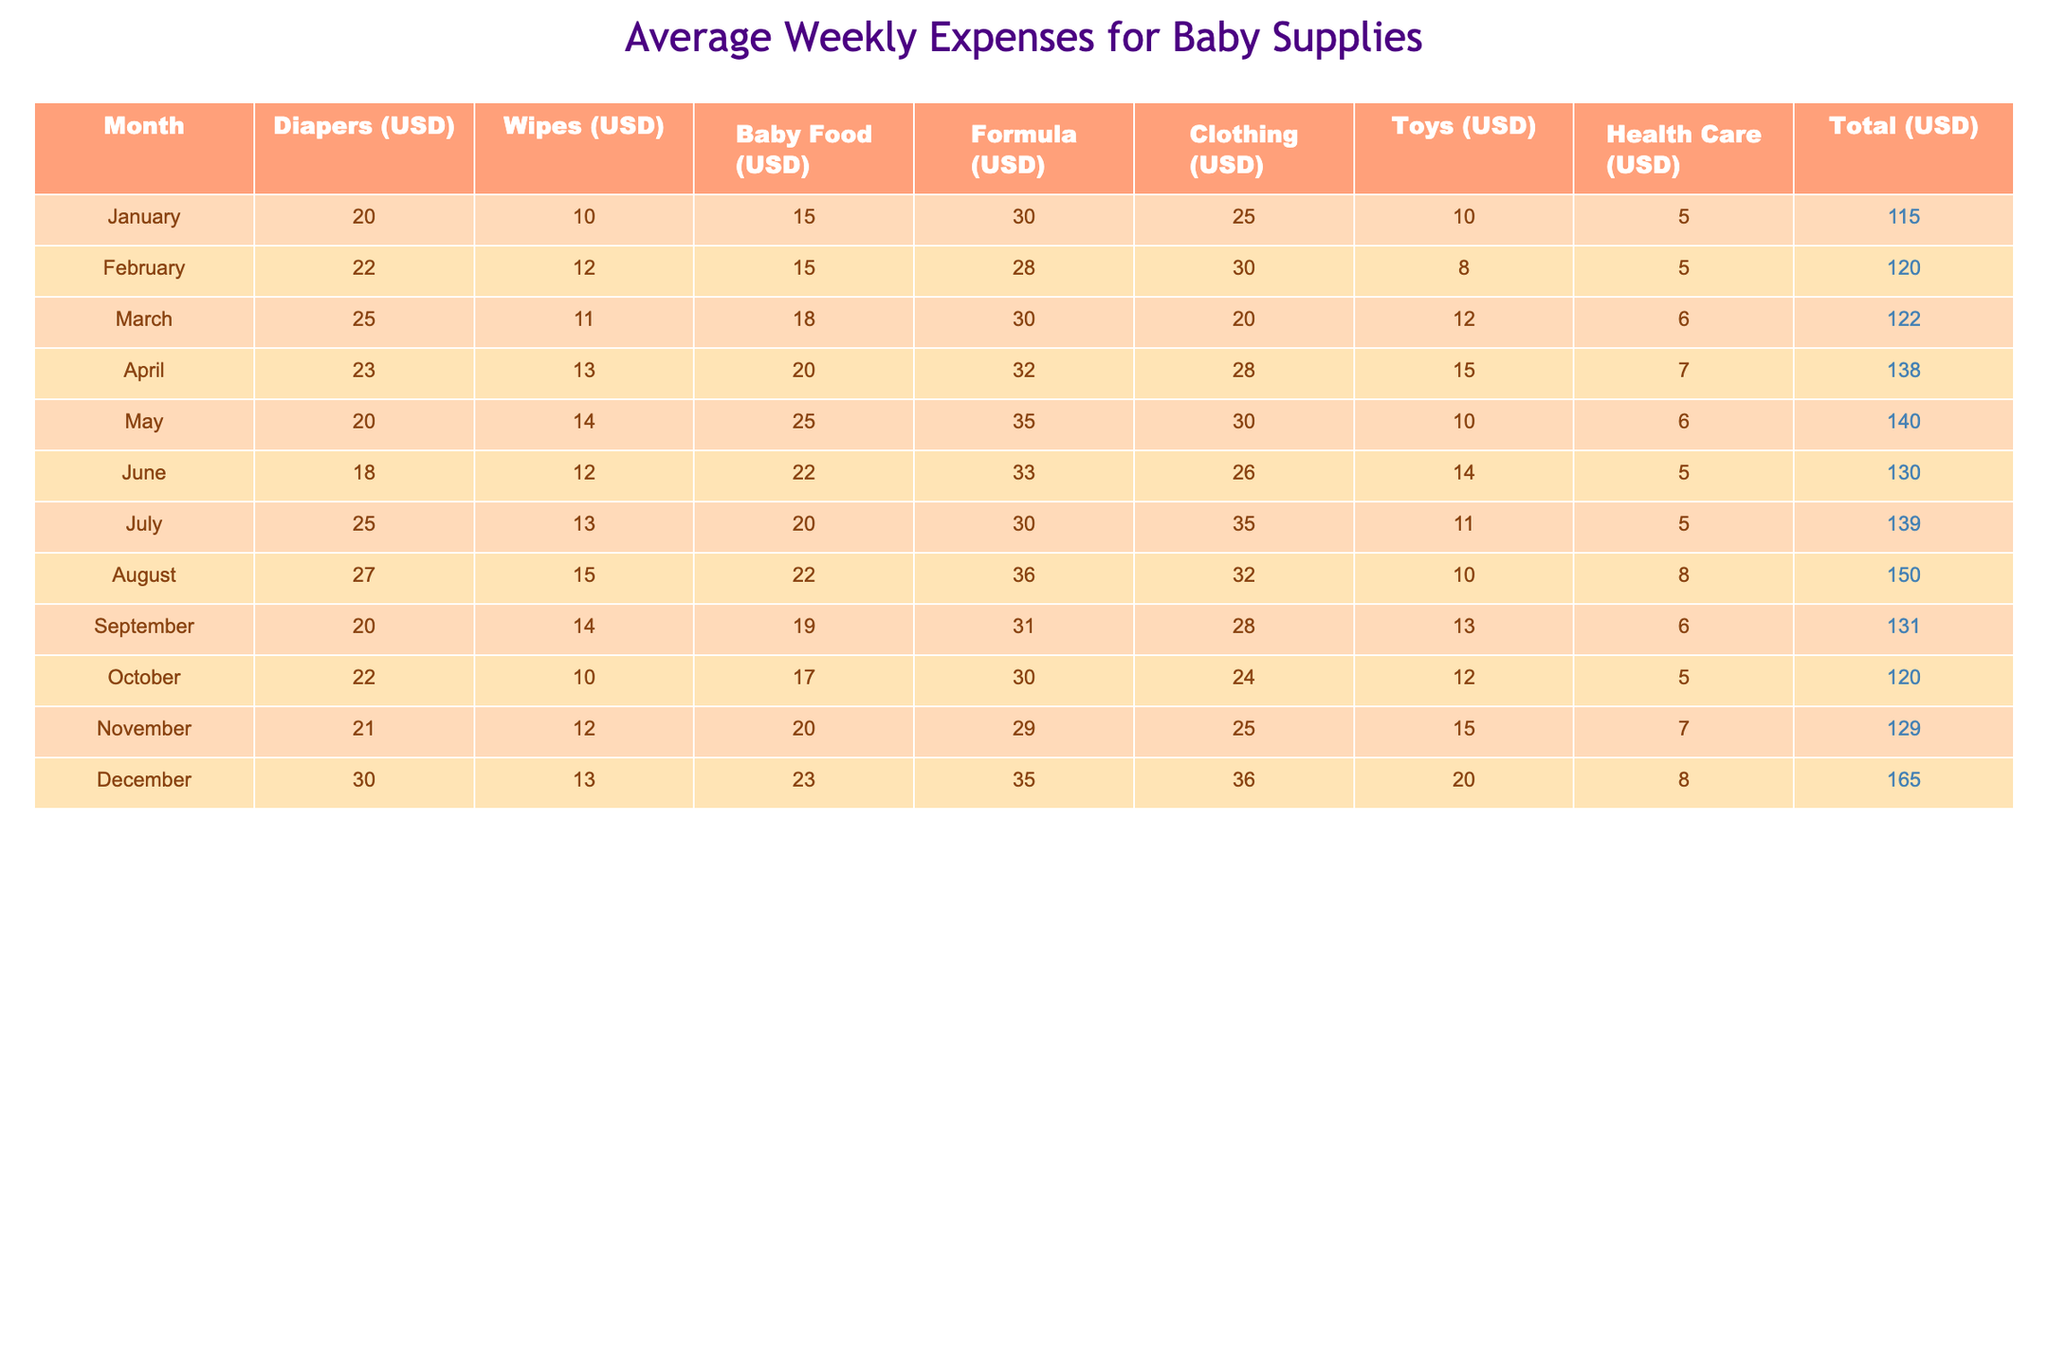What is the total average weekly expense for baby supplies in December? In December, the total average weekly expense listed in the table is 165 USD.
Answer: 165 Which month had the highest expense for clothing? The highest expense for clothing was in December, where it is listed as 36 USD.
Answer: December What was the average weekly expense of formula over the year? Adding the formula expenses for each month: (30 + 28 + 30 + 32 + 35 + 33 + 30 + 36 + 31 + 30 + 29 + 35) = 390. There are 12 months, so the average formula expense is 390/12 = 32.5 USD.
Answer: 32.5 Did the total average weekly expenses increase from January to December? Yes, in January the total expense was 115 USD and in December it was 165 USD. Thus, the expenses increased.
Answer: Yes Which month had a total expense closest to 130 USD? The closest total expense to 130 USD is in June, where it is listed as 130 USD.
Answer: June Which was the least expensive month for baby food? The least expense for baby food was in January at 15 USD.
Answer: January How much more was spent on healthcare in August compared to May? In August, health care expenses were 8 USD and in May it was 6 USD. The difference is 8 - 6 = 2 USD.
Answer: 2 Is the average weekly expense for toys higher in the second half of the year compared to the first half? In the first half, the average toy expense is (10 + 8 + 12 + 15 + 10 + 14) = 69/6 = 11.5 USD. In the second half, it is (11 + 10 + 13 + 20 + 15 + 20) = 99/6 = 16.5 USD. Thus, yes, it is higher in the second half.
Answer: Yes What was the total expense for diapers from January to March? The total expenses for diapers are: 20 (January) + 22 (February) + 25 (March) = 67 USD.
Answer: 67 